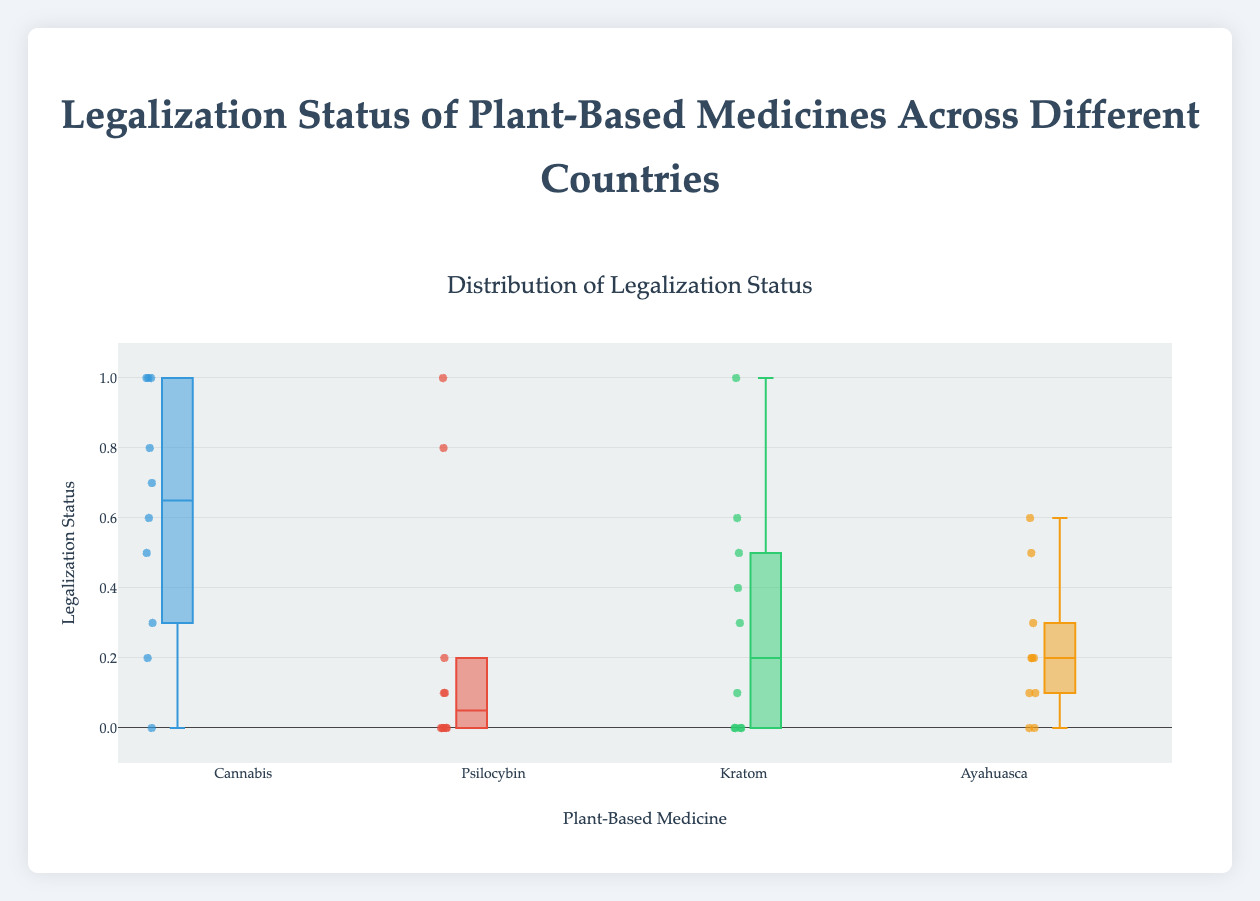What is the title of the figure? The title is shown prominently at the top of the figure. It reads "Distribution of Legalization Status."
Answer: Distribution of Legalization Status How many plant-based medicines are being compared in this figure? The figure contains four separate box plots, one for each plant-based medicine. Therefore, we can see that four different plant-based medicines are being compared.
Answer: Four Which plant-based medicine has the most variation in legalization status across the countries? We need to visually compare the spread (interquartile range and whiskers) of the box plots. Cannabis has the widest spread from around 0 to 1, indicating the most variation.
Answer: Cannabis Which plant-based medicine has the highest median legalization status? The median is indicated by the line inside the box in each box plot. Psilocybin has a median near 0, whereas Cannabis has a median around 0.8.
Answer: Cannabis Which plant-based medicine has the lowest maximum legalization status? The maximum value is indicated by the top whisker in the box plot. Ayahuasca and Kratom have their top whiskers touching 0.6, while Cannabis and Psilocybin go higher. Thus, Kratom and Ayahuasca have the lowest maximum legalization status.
Answer: Kratom and Ayahuasca What is the median legalization status for Ayahuasca? The median is shown as a line in the middle of the box. For Ayahuasca, the median is approximately at 0.2.
Answer: 0.2 How does the interquartile range (IQR) of Cannabis compare to that of Kratom? The IQR is the range between the first and third quartiles (the box). The IQR for Cannabis is larger than that of Kratom.
Answer: Cannabis has a larger IQR What is the spread of legalization status for Psilocybin (i.e., minimum and maximum values)? The spread is indicated by the bottom and top whiskers of the box plot for Psilocybin. The minimum value is 0, and the maximum value is 1.
Answer: 0 to 1 What countries have a legalization status of 1 for Cannabis? The individual points on the box plot for Cannabis at the value of 1 can be checked. For example, USA and Canada correspond to these points.
Answer: USA, Canada, Netherlands 